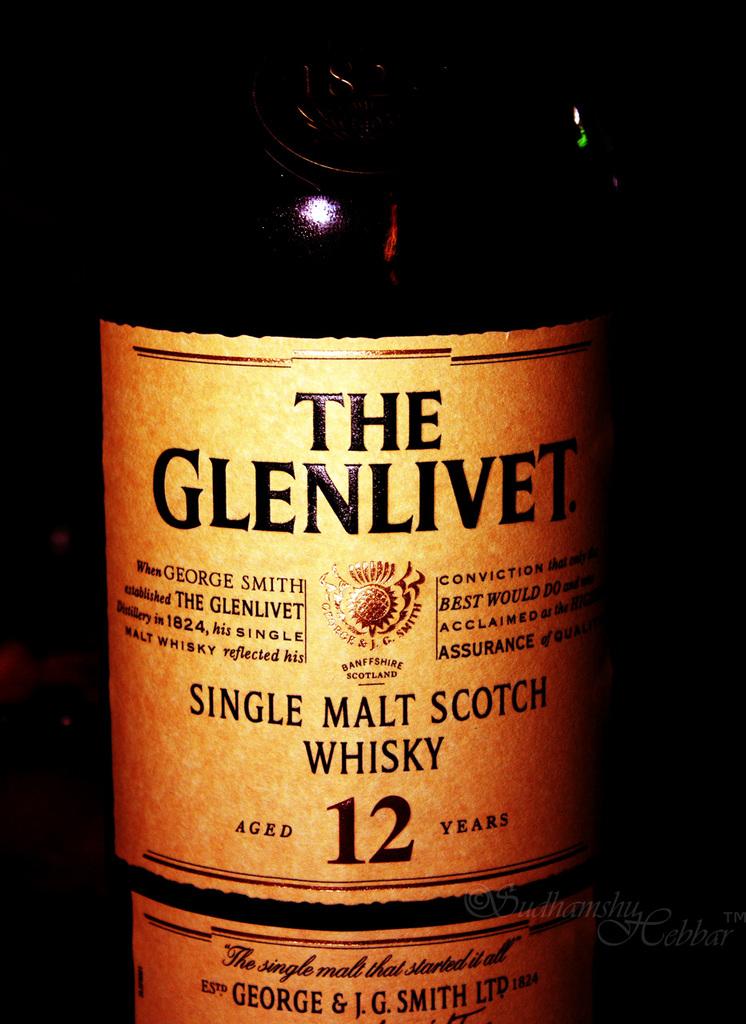What is in the bottle?
Provide a short and direct response. Single malt scotch whisky. How many years is the bottle aged?
Provide a short and direct response. 12. 